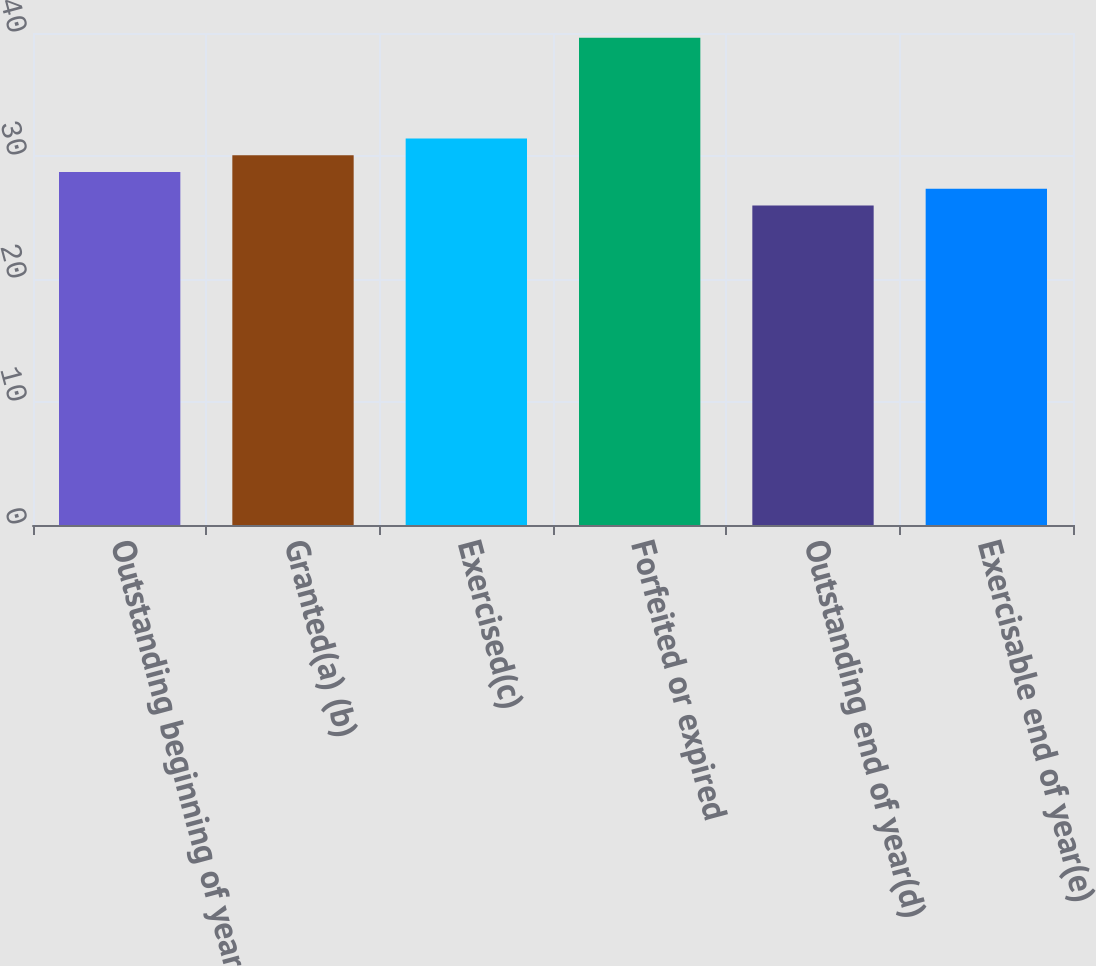<chart> <loc_0><loc_0><loc_500><loc_500><bar_chart><fcel>Outstanding beginning of year<fcel>Granted(a) (b)<fcel>Exercised(c)<fcel>Forfeited or expired<fcel>Outstanding end of year(d)<fcel>Exercisable end of year(e)<nl><fcel>28.7<fcel>30.06<fcel>31.42<fcel>39.62<fcel>25.98<fcel>27.34<nl></chart> 